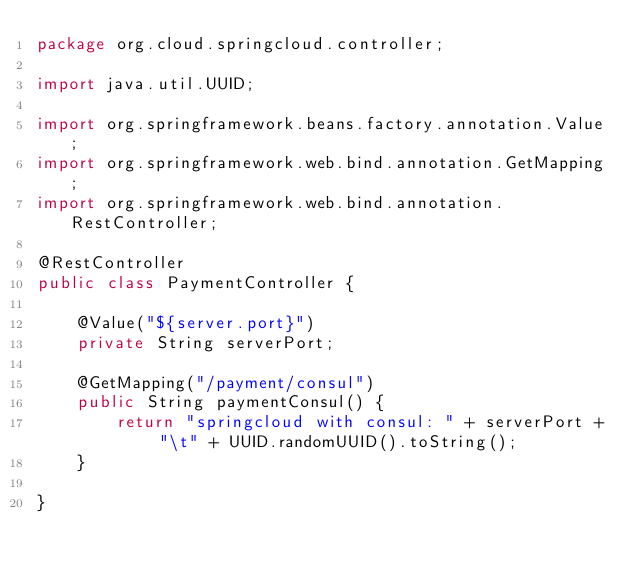Convert code to text. <code><loc_0><loc_0><loc_500><loc_500><_Java_>package org.cloud.springcloud.controller;

import java.util.UUID;

import org.springframework.beans.factory.annotation.Value;
import org.springframework.web.bind.annotation.GetMapping;
import org.springframework.web.bind.annotation.RestController;

@RestController
public class PaymentController {

    @Value("${server.port}")
    private String serverPort;

    @GetMapping("/payment/consul")
    public String paymentConsul() {
        return "springcloud with consul: " + serverPort + "\t" + UUID.randomUUID().toString();
    }

}
</code> 